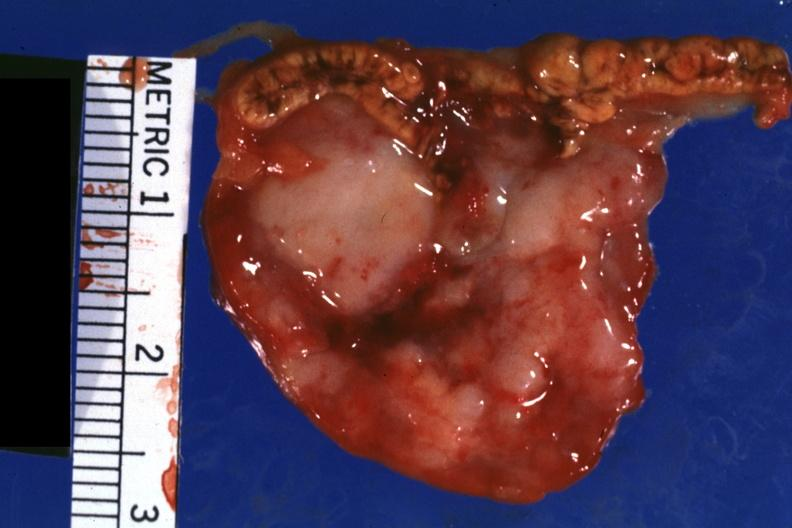s endocrine present?
Answer the question using a single word or phrase. Yes 